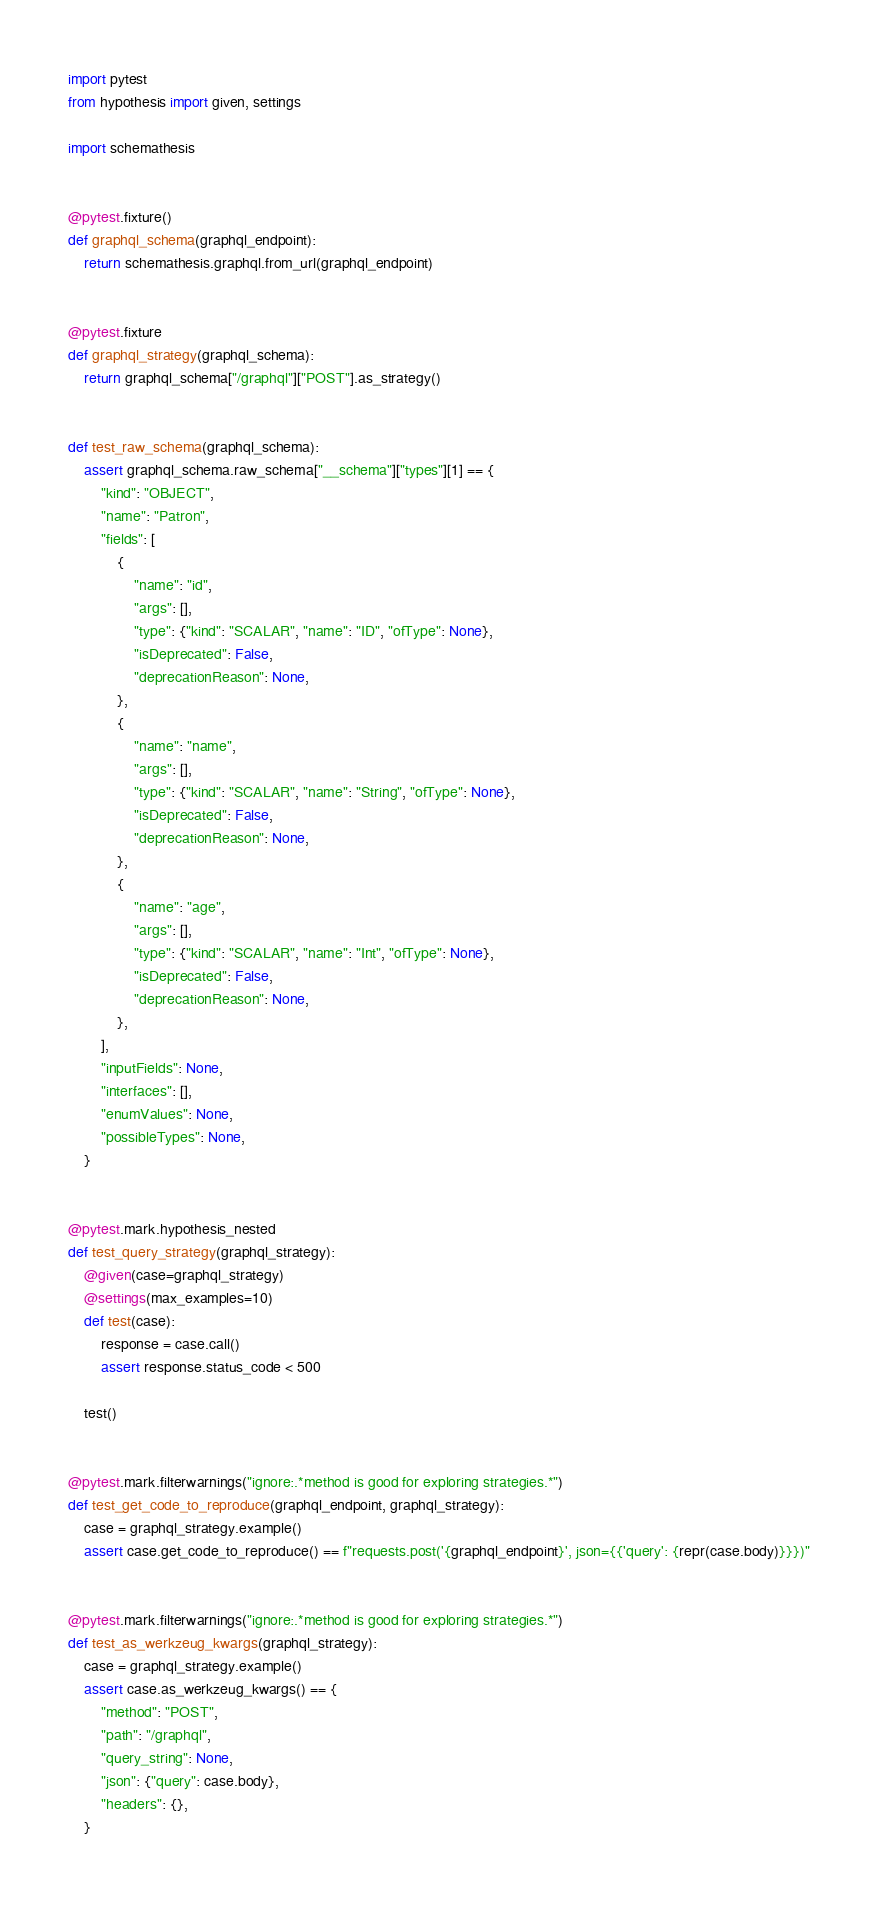Convert code to text. <code><loc_0><loc_0><loc_500><loc_500><_Python_>import pytest
from hypothesis import given, settings

import schemathesis


@pytest.fixture()
def graphql_schema(graphql_endpoint):
    return schemathesis.graphql.from_url(graphql_endpoint)


@pytest.fixture
def graphql_strategy(graphql_schema):
    return graphql_schema["/graphql"]["POST"].as_strategy()


def test_raw_schema(graphql_schema):
    assert graphql_schema.raw_schema["__schema"]["types"][1] == {
        "kind": "OBJECT",
        "name": "Patron",
        "fields": [
            {
                "name": "id",
                "args": [],
                "type": {"kind": "SCALAR", "name": "ID", "ofType": None},
                "isDeprecated": False,
                "deprecationReason": None,
            },
            {
                "name": "name",
                "args": [],
                "type": {"kind": "SCALAR", "name": "String", "ofType": None},
                "isDeprecated": False,
                "deprecationReason": None,
            },
            {
                "name": "age",
                "args": [],
                "type": {"kind": "SCALAR", "name": "Int", "ofType": None},
                "isDeprecated": False,
                "deprecationReason": None,
            },
        ],
        "inputFields": None,
        "interfaces": [],
        "enumValues": None,
        "possibleTypes": None,
    }


@pytest.mark.hypothesis_nested
def test_query_strategy(graphql_strategy):
    @given(case=graphql_strategy)
    @settings(max_examples=10)
    def test(case):
        response = case.call()
        assert response.status_code < 500

    test()


@pytest.mark.filterwarnings("ignore:.*method is good for exploring strategies.*")
def test_get_code_to_reproduce(graphql_endpoint, graphql_strategy):
    case = graphql_strategy.example()
    assert case.get_code_to_reproduce() == f"requests.post('{graphql_endpoint}', json={{'query': {repr(case.body)}}})"


@pytest.mark.filterwarnings("ignore:.*method is good for exploring strategies.*")
def test_as_werkzeug_kwargs(graphql_strategy):
    case = graphql_strategy.example()
    assert case.as_werkzeug_kwargs() == {
        "method": "POST",
        "path": "/graphql",
        "query_string": None,
        "json": {"query": case.body},
        "headers": {},
    }
</code> 